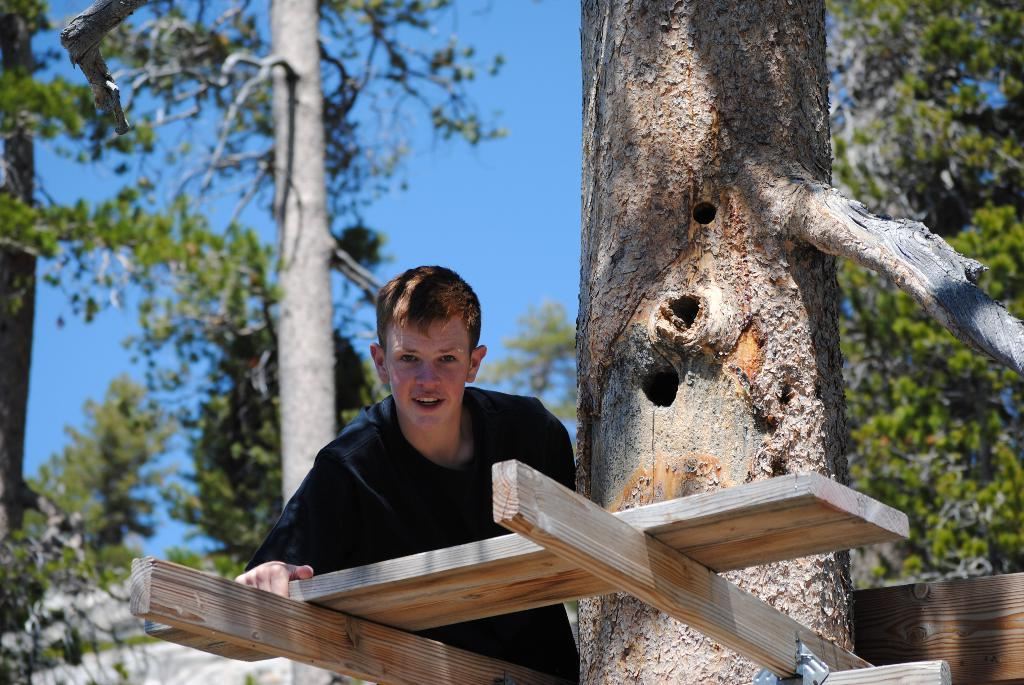What is located in the foreground of the picture? There is a boy and wooden logs in the foreground of the picture. What else can be seen in the foreground of the picture? There is also a tree trunk in the foreground of the picture. What is visible in the background of the image? The background of the image is blurred, but there are trees visible. How would you describe the weather in the image? The sky is sunny, suggesting a clear and bright day. How many people are in the crowd at the market in the image? There is no crowd or market present in the image; it features a boy, wooden logs, and a tree trunk in the foreground, with a blurred background of trees and a sunny sky. What decision did the boy make in the image? There is no indication of a decision being made by the boy in the image. 